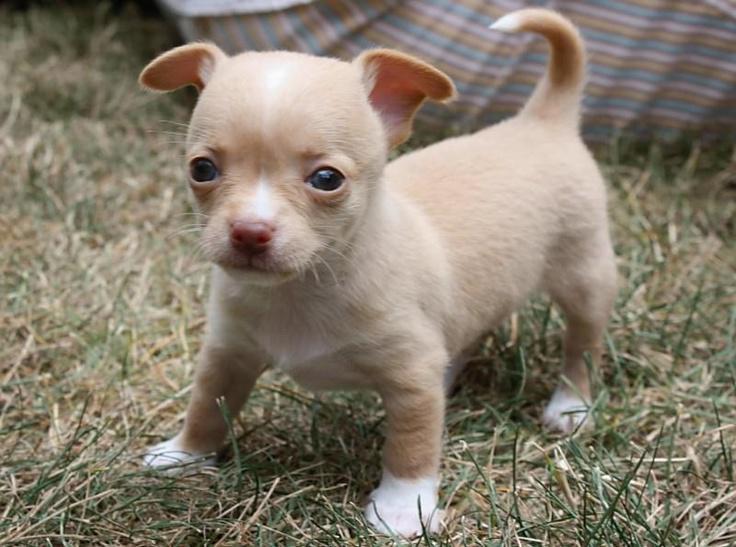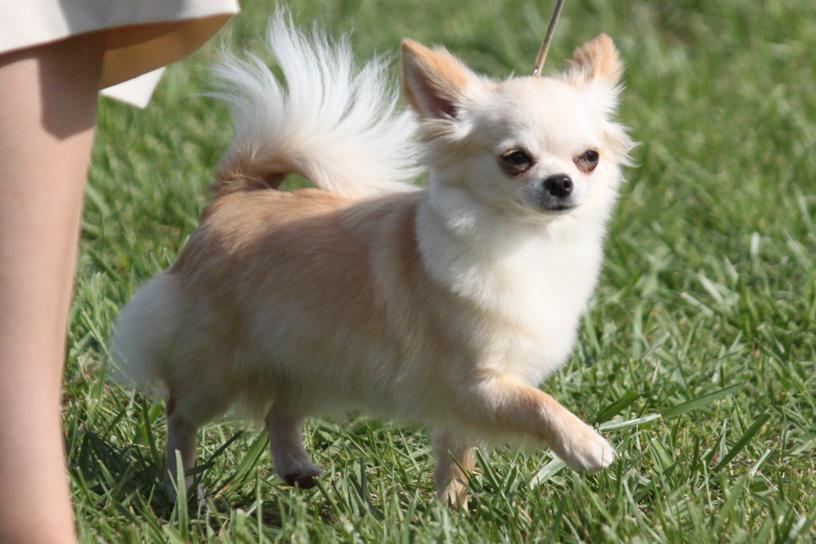The first image is the image on the left, the second image is the image on the right. Examine the images to the left and right. Is the description "At least one of the images features a single dog and shows grass in the image" accurate? Answer yes or no. Yes. The first image is the image on the left, the second image is the image on the right. Evaluate the accuracy of this statement regarding the images: "A leash extends from the small dog in the right-hand image.". Is it true? Answer yes or no. Yes. 